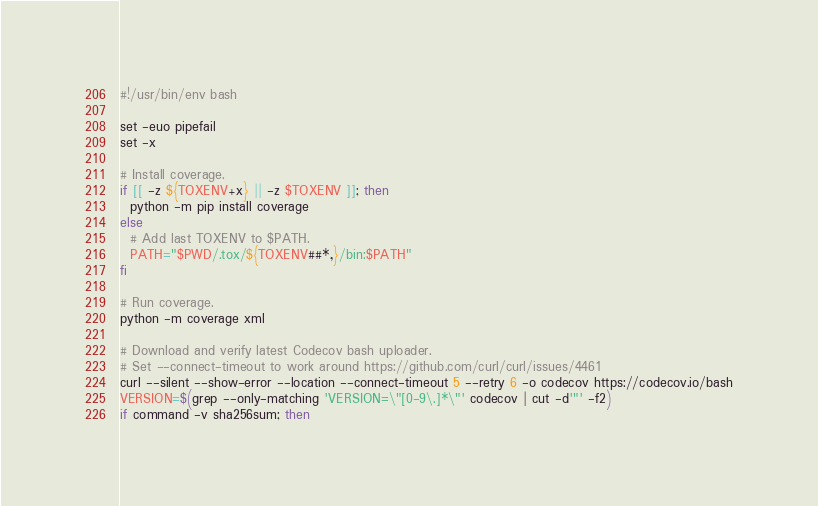<code> <loc_0><loc_0><loc_500><loc_500><_Bash_>#!/usr/bin/env bash

set -euo pipefail
set -x

# Install coverage.
if [[ -z ${TOXENV+x} || -z $TOXENV ]]; then
  python -m pip install coverage
else
  # Add last TOXENV to $PATH.
  PATH="$PWD/.tox/${TOXENV##*,}/bin:$PATH"
fi

# Run coverage.
python -m coverage xml

# Download and verify latest Codecov bash uploader.
# Set --connect-timeout to work around https://github.com/curl/curl/issues/4461
curl --silent --show-error --location --connect-timeout 5 --retry 6 -o codecov https://codecov.io/bash
VERSION=$(grep --only-matching 'VERSION=\"[0-9\.]*\"' codecov | cut -d'"' -f2)
if command -v sha256sum; then</code> 